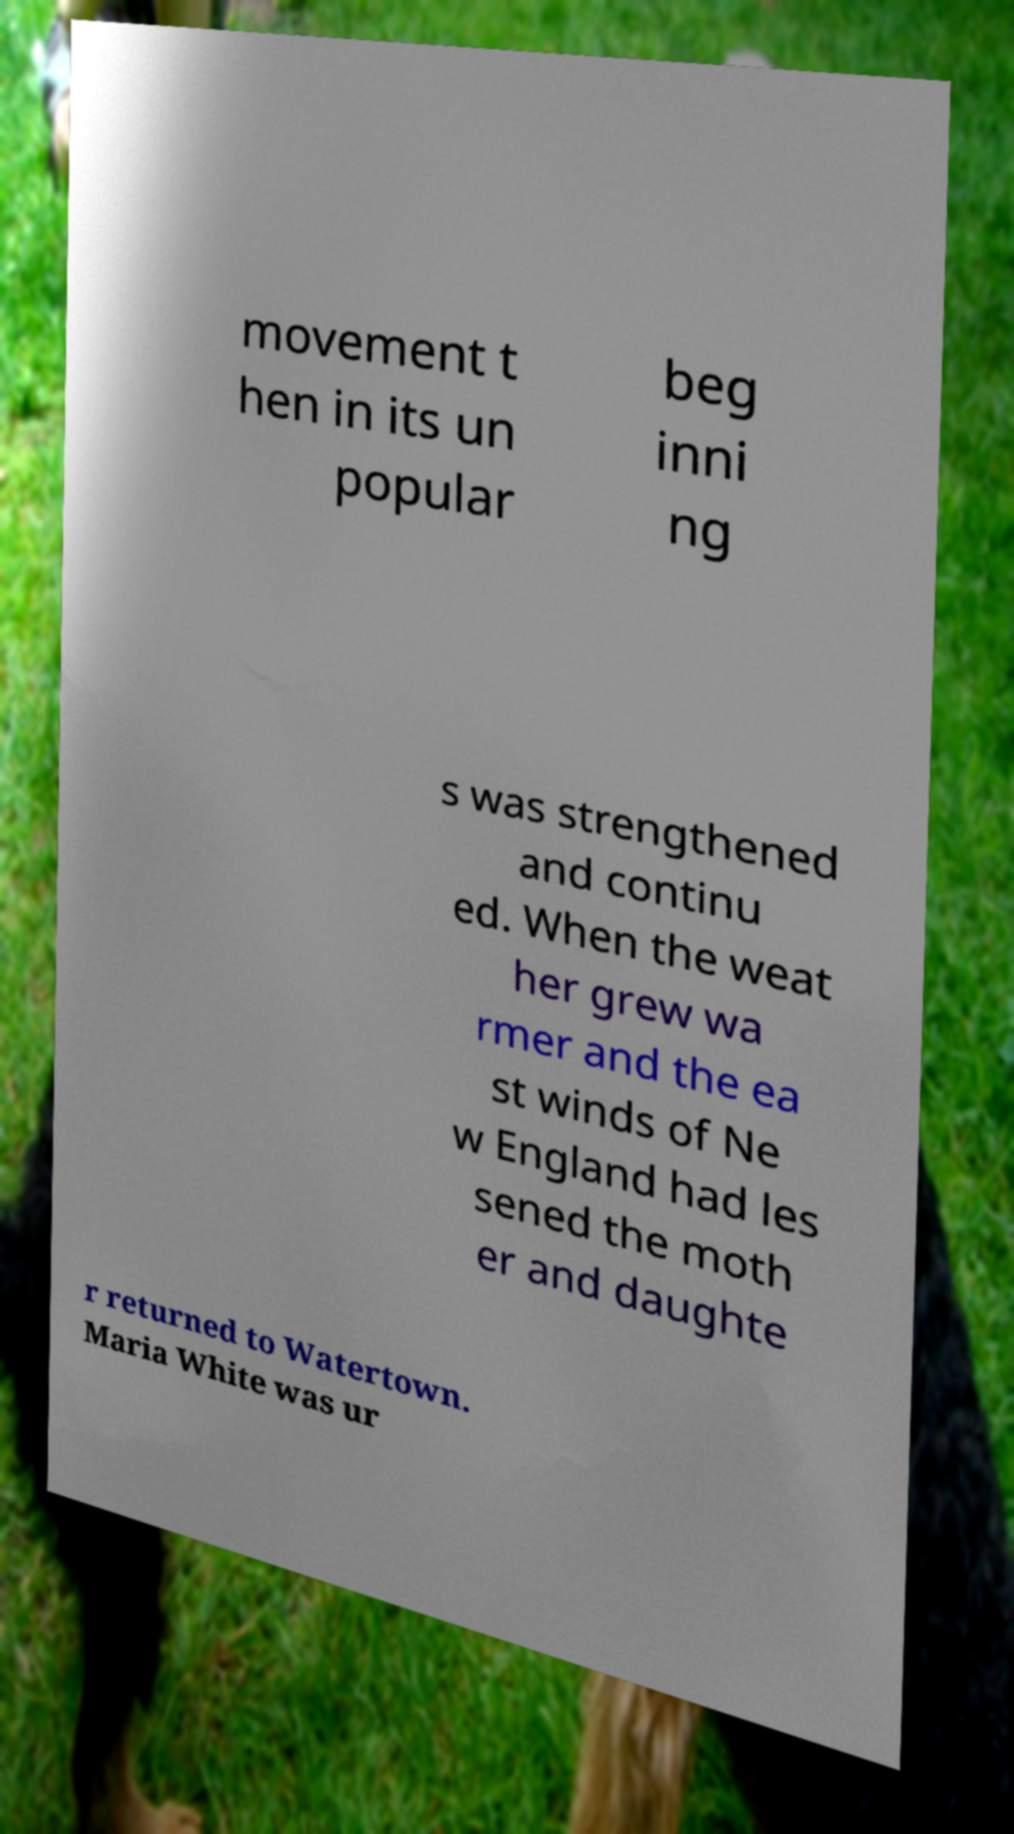For documentation purposes, I need the text within this image transcribed. Could you provide that? movement t hen in its un popular beg inni ng s was strengthened and continu ed. When the weat her grew wa rmer and the ea st winds of Ne w England had les sened the moth er and daughte r returned to Watertown. Maria White was ur 